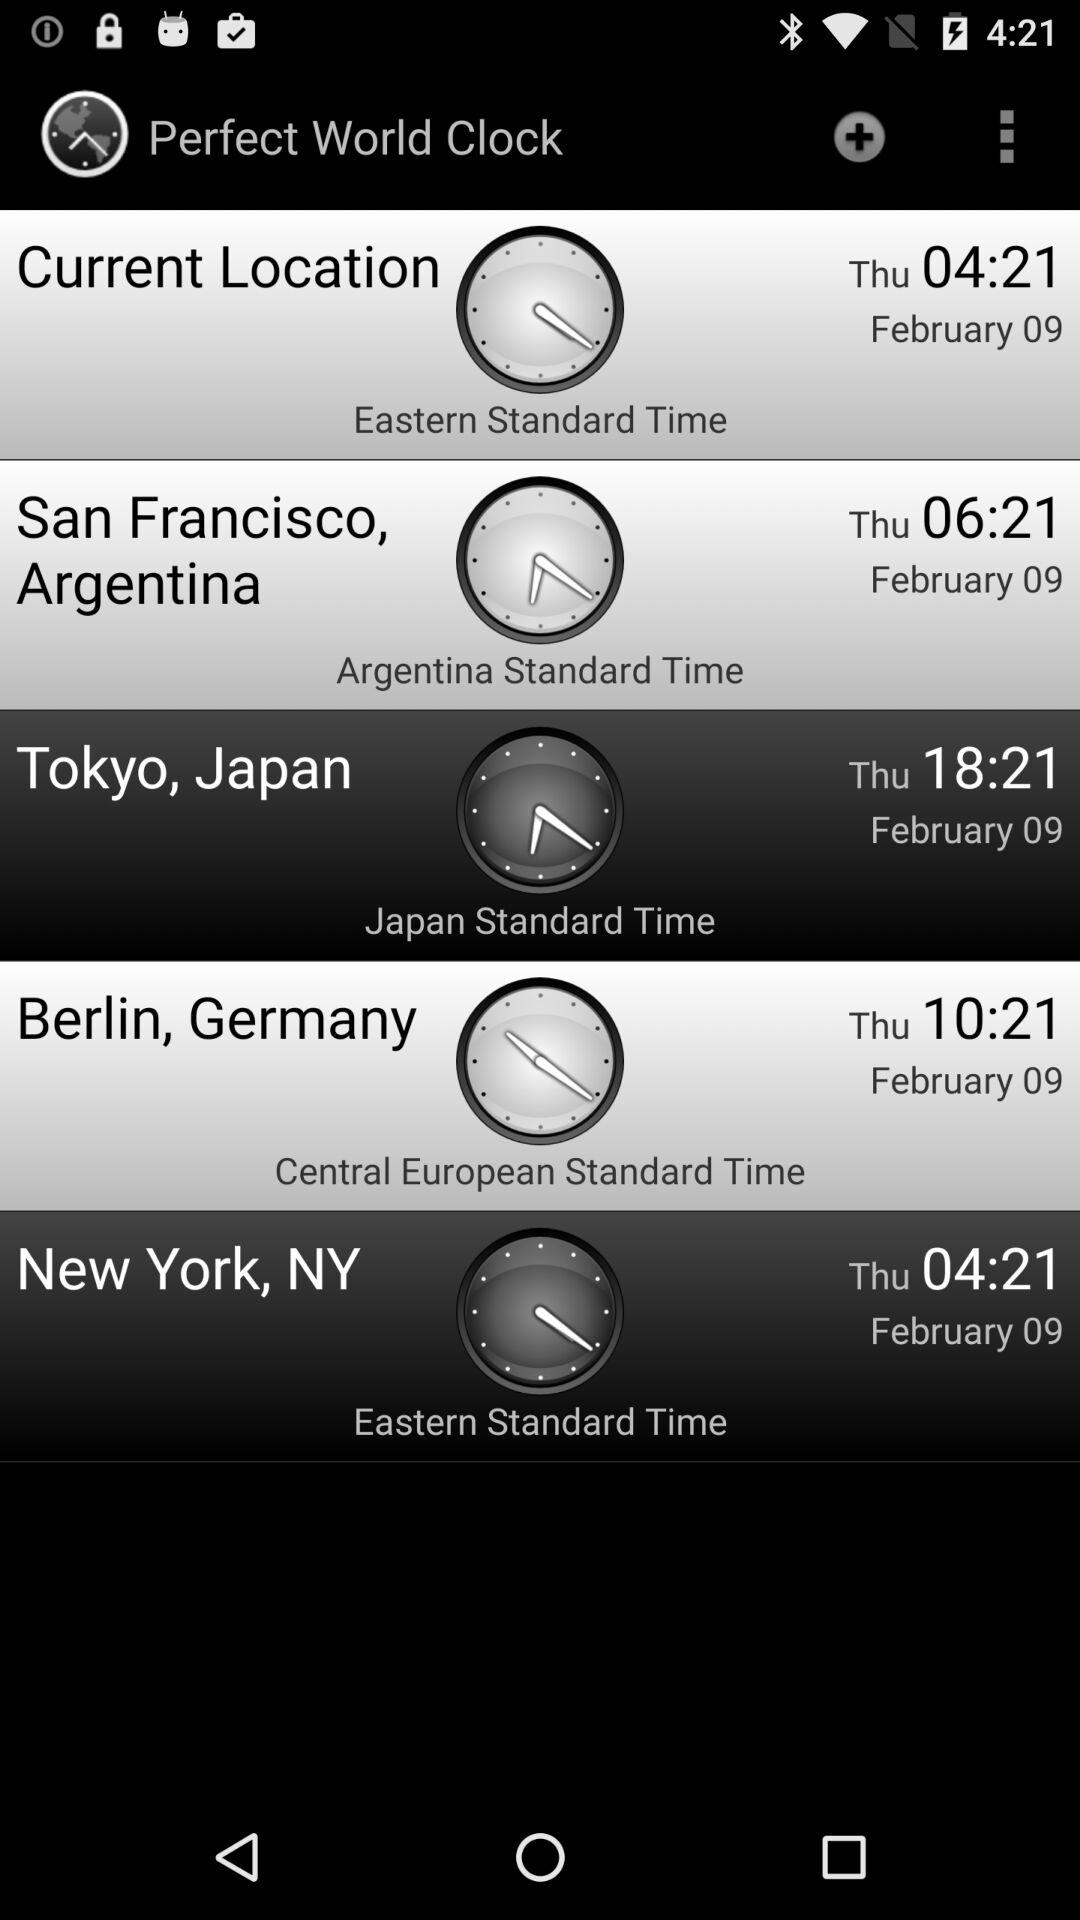What is the time in Japan Standard Time? The time is 18:21. 